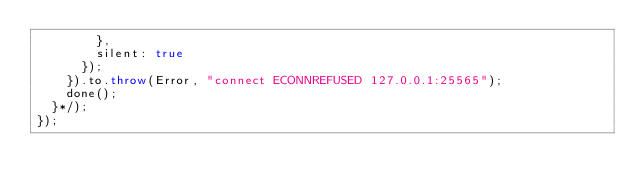Convert code to text. <code><loc_0><loc_0><loc_500><loc_500><_JavaScript_>        },
        silent: true
      });
    }).to.throw(Error, "connect ECONNREFUSED 127.0.0.1:25565");
    done();
  }*/);
});
</code> 